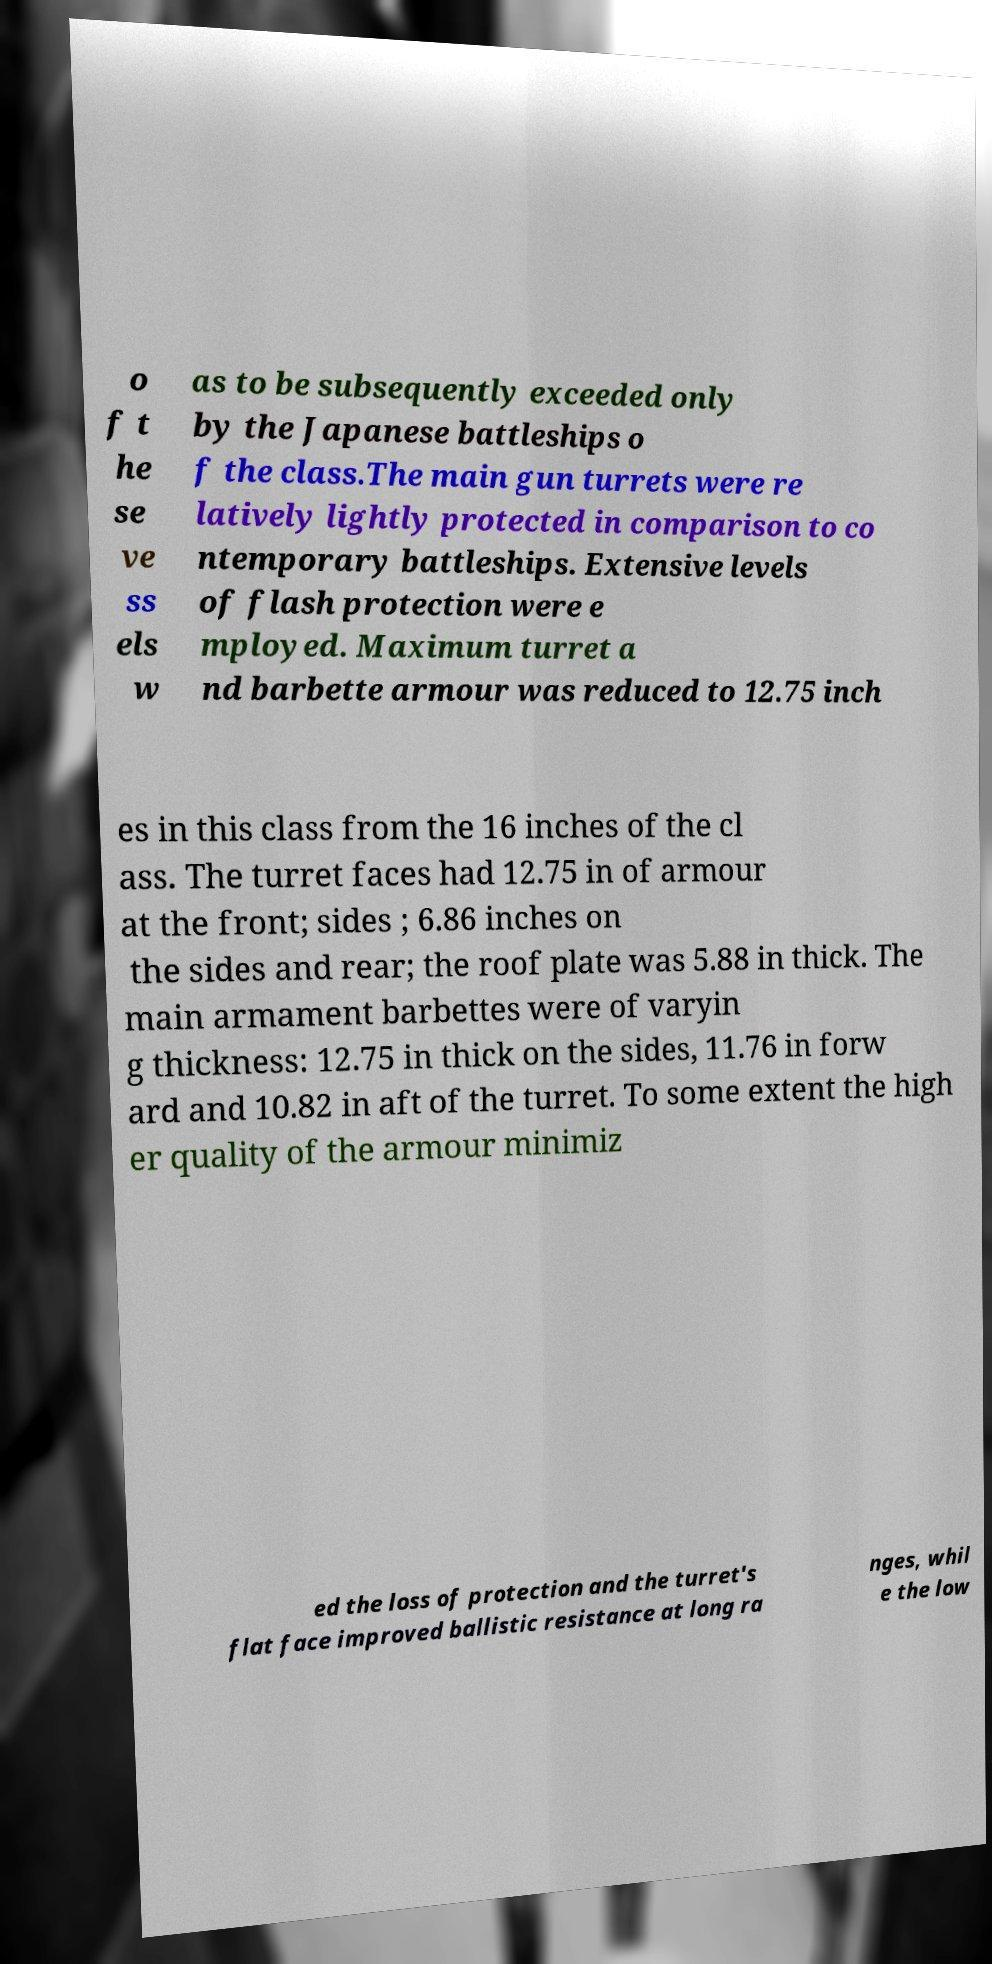Please read and relay the text visible in this image. What does it say? o f t he se ve ss els w as to be subsequently exceeded only by the Japanese battleships o f the class.The main gun turrets were re latively lightly protected in comparison to co ntemporary battleships. Extensive levels of flash protection were e mployed. Maximum turret a nd barbette armour was reduced to 12.75 inch es in this class from the 16 inches of the cl ass. The turret faces had 12.75 in of armour at the front; sides ; 6.86 inches on the sides and rear; the roof plate was 5.88 in thick. The main armament barbettes were of varyin g thickness: 12.75 in thick on the sides, 11.76 in forw ard and 10.82 in aft of the turret. To some extent the high er quality of the armour minimiz ed the loss of protection and the turret's flat face improved ballistic resistance at long ra nges, whil e the low 